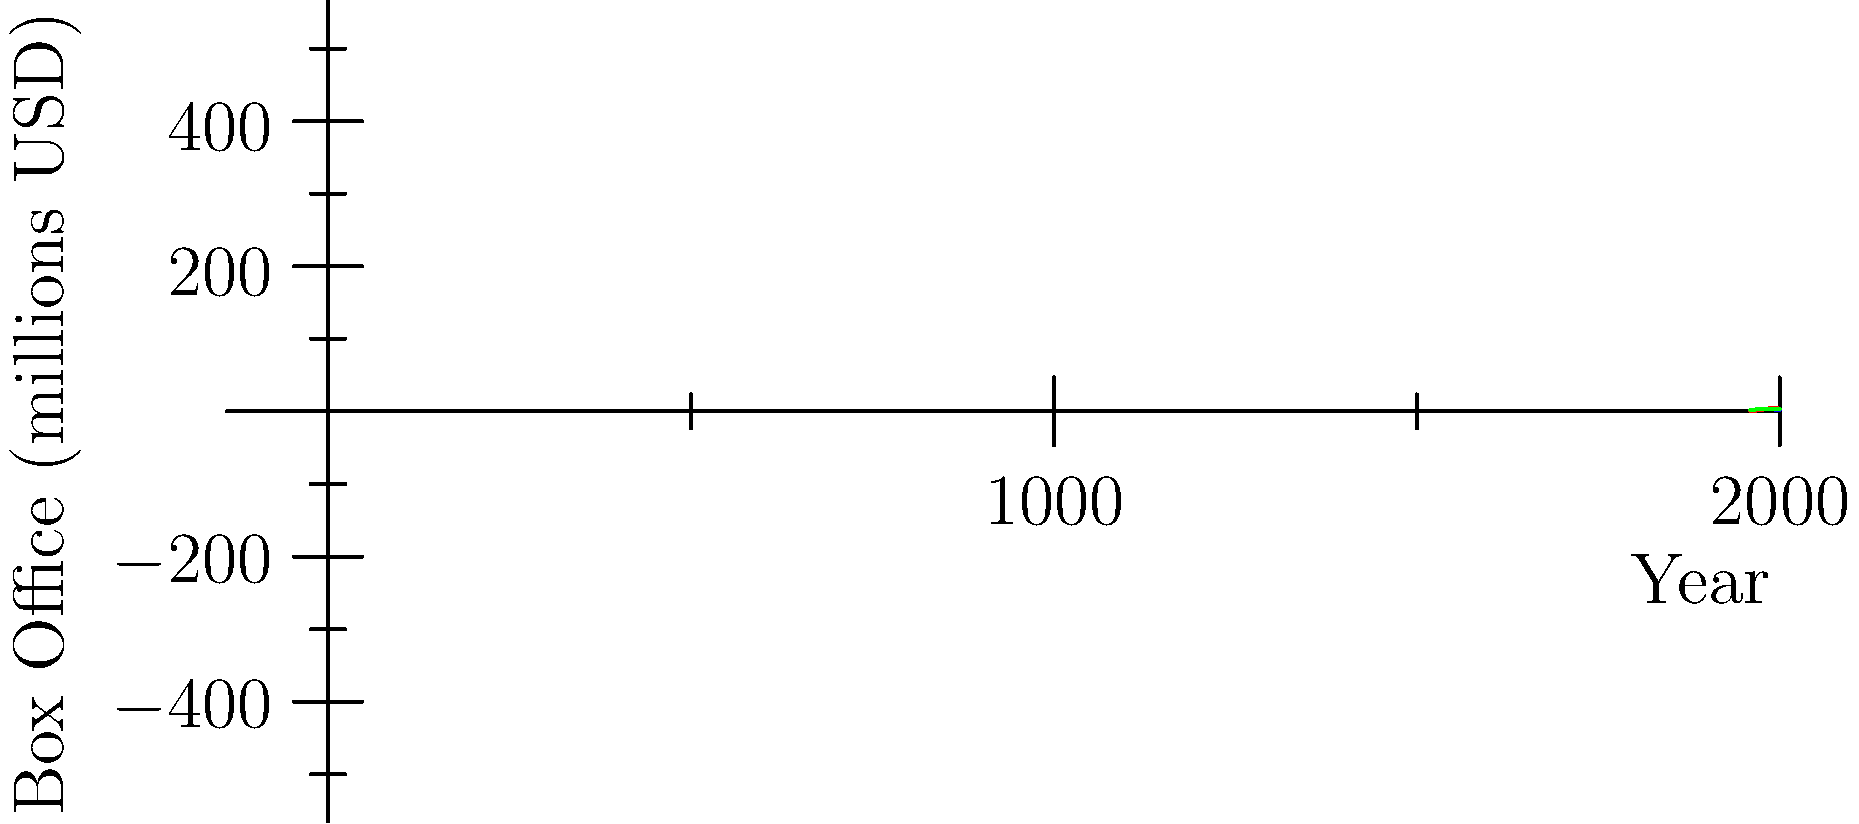The line graph shows the box office trends of three classic Southeast Asian films over five decades. Which film experienced the most significant increase in box office revenue between 1960 and 1990? To determine which film had the most significant increase in box office revenue between 1960 and 1990, we need to calculate the change for each film:

1. Film A:
   1960 value: $1 million
   1990 value: $3 million
   Increase: $3 million - $1 million = $2 million

2. Film B:
   1960 value: $0.5 million
   1990 value: $5 million
   Increase: $5 million - $0.5 million = $4.5 million

3. Film C:
   1960 value: $2 million
   1990 value: $4 million
   Increase: $4 million - $2 million = $2 million

Film B had the largest increase of $4.5 million from 1960 to 1990, significantly higher than the other two films.
Answer: Film B 